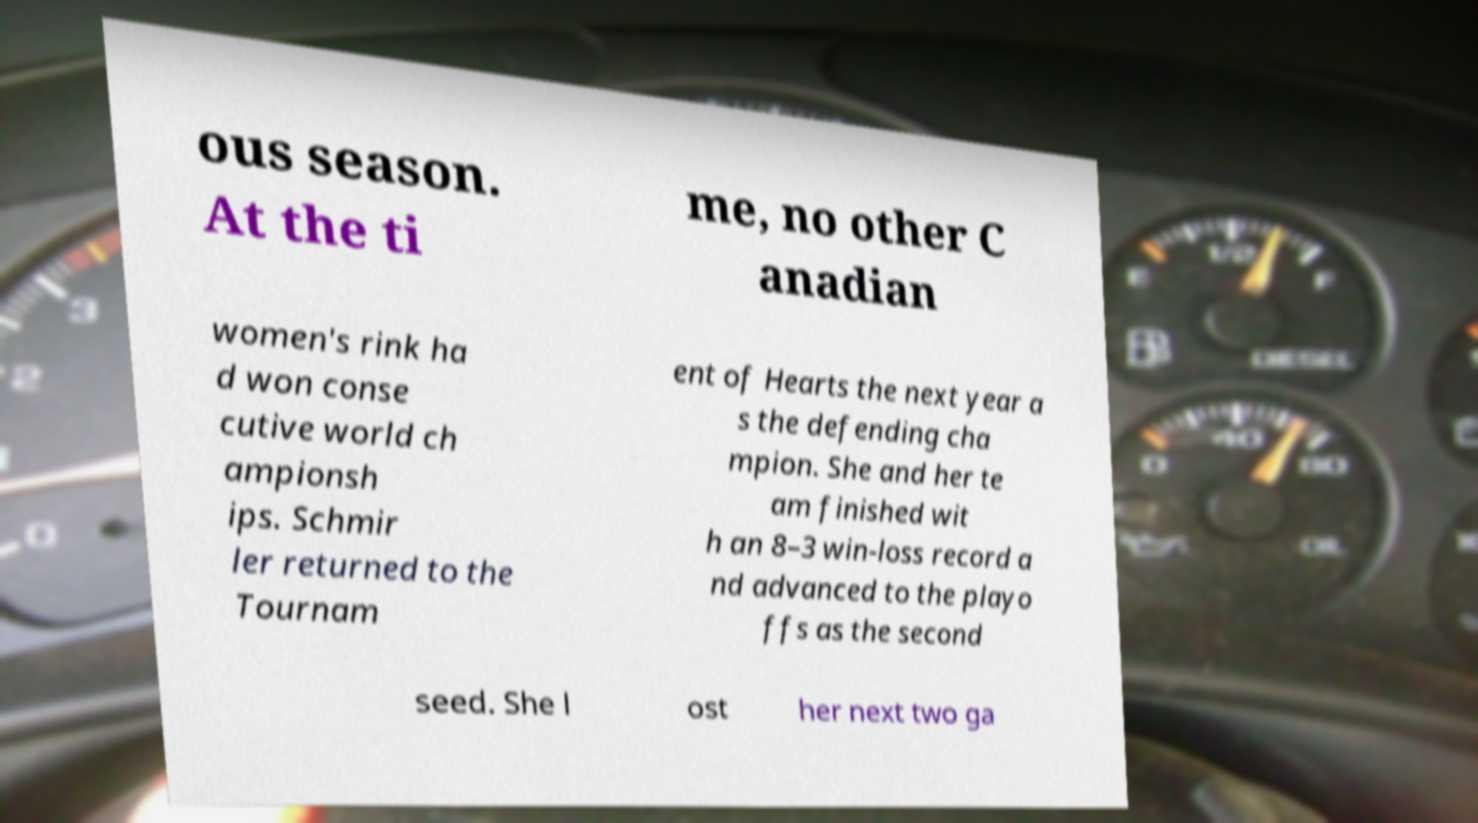I need the written content from this picture converted into text. Can you do that? ous season. At the ti me, no other C anadian women's rink ha d won conse cutive world ch ampionsh ips. Schmir ler returned to the Tournam ent of Hearts the next year a s the defending cha mpion. She and her te am finished wit h an 8–3 win-loss record a nd advanced to the playo ffs as the second seed. She l ost her next two ga 